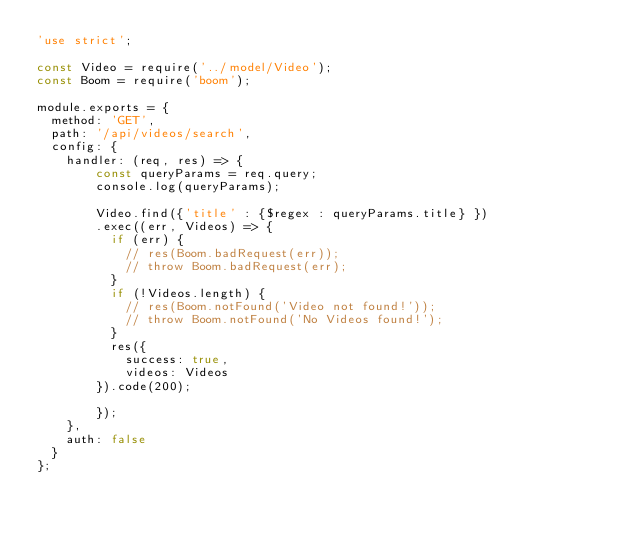Convert code to text. <code><loc_0><loc_0><loc_500><loc_500><_JavaScript_>'use strict';

const Video = require('../model/Video');
const Boom = require('boom');

module.exports = {
  method: 'GET',
  path: '/api/videos/search',
  config: {
    handler: (req, res) => {
        const queryParams = req.query;
        console.log(queryParams);

        Video.find({'title' : {$regex : queryParams.title} })
        .exec((err, Videos) => {
          if (err) {
            // res(Boom.badRequest(err));
            // throw Boom.badRequest(err);
          }
          if (!Videos.length) {
            // res(Boom.notFound('Video not found!'));
            // throw Boom.notFound('No Videos found!');
          }
          res({
            success: true,
            videos: Videos
        }).code(200);
          
        });
    },
    auth: false
  }
};</code> 